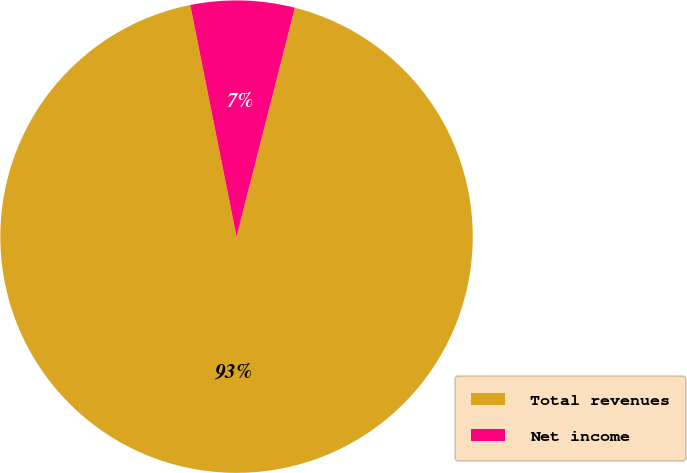Convert chart to OTSL. <chart><loc_0><loc_0><loc_500><loc_500><pie_chart><fcel>Total revenues<fcel>Net income<nl><fcel>92.89%<fcel>7.11%<nl></chart> 